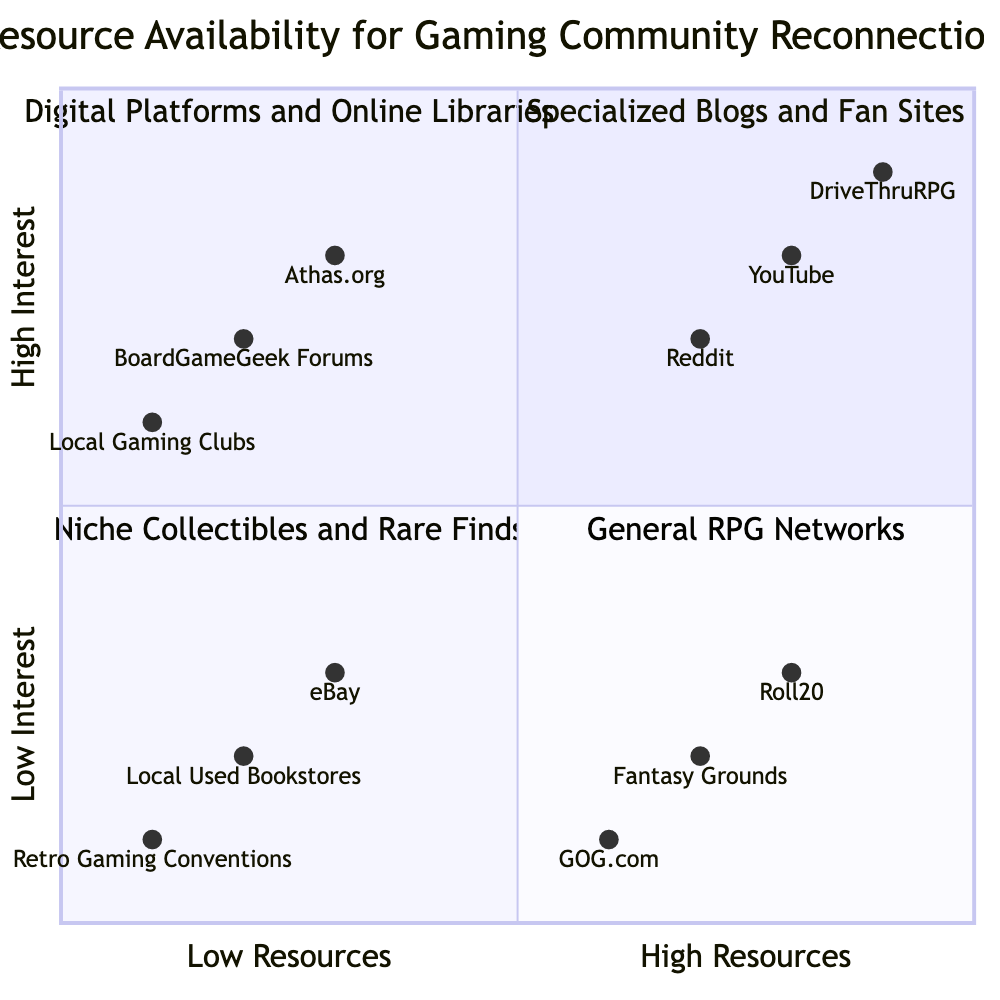What category includes DriveThruRPG? DriveThruRPG is located in the quadrant for "Digital Platforms and Online Libraries," which is situated in the top right section of the diagram (representing high community interest and abundant resources).
Answer: Digital Platforms and Online Libraries How many elements are in Limited Resources with High Community Interest? In the quadrant designated for "Specialized Blogs and Fan Sites," there are three elements listed, which represent Limited Resources and High Community Interest.
Answer: 3 What is the highest interest score in the chart? The highest interest score is 0.9, found in both DriveThruRPG and YouTube, which are in the top right quadrant indicating high interest and abundant resources.
Answer: 0.9 Which category has abundant resources but low community interest? The quadrant for "General RPG Networks," located in the bottom right, contains resources that are abundant but have low community interest.
Answer: General RPG Networks What element is the least available in terms of resources? The element "Retro Gaming Conventions," positioned in the bottom left quadrant, reflects limited resources and low community interest, indicating it is the least available option.
Answer: Retro Gaming Conventions Identify the element with the most significant community interest in this data set. DriveThruRPG has the highest interest score of 0.9 and is also abundant in resources, which makes it the most significant with regard to community interest.
Answer: DriveThruRPG How many total elements are represented in the chart? The total number of elements can be summed from each quadrant: there are 3 in the top left, 3 in the top right, 3 in the bottom left, and 3 in the bottom right, making a total of 12 elements.
Answer: 12 Which element provides virtual tabletop tools that include Dark Sun options? The element that provides virtual tabletop tools including Dark Sun options is Roll20, located in the bottom right quadrant of the chart.
Answer: Roll20 Which quadrant has a focus on Niche Collectibles and Rare Finds? The bottom left quadrant of the diagram is dedicated to resources categorized as "Niche Collectibles and Rare Finds," indicating limited resources alongside low community interest.
Answer: Niche Collectibles and Rare Finds 